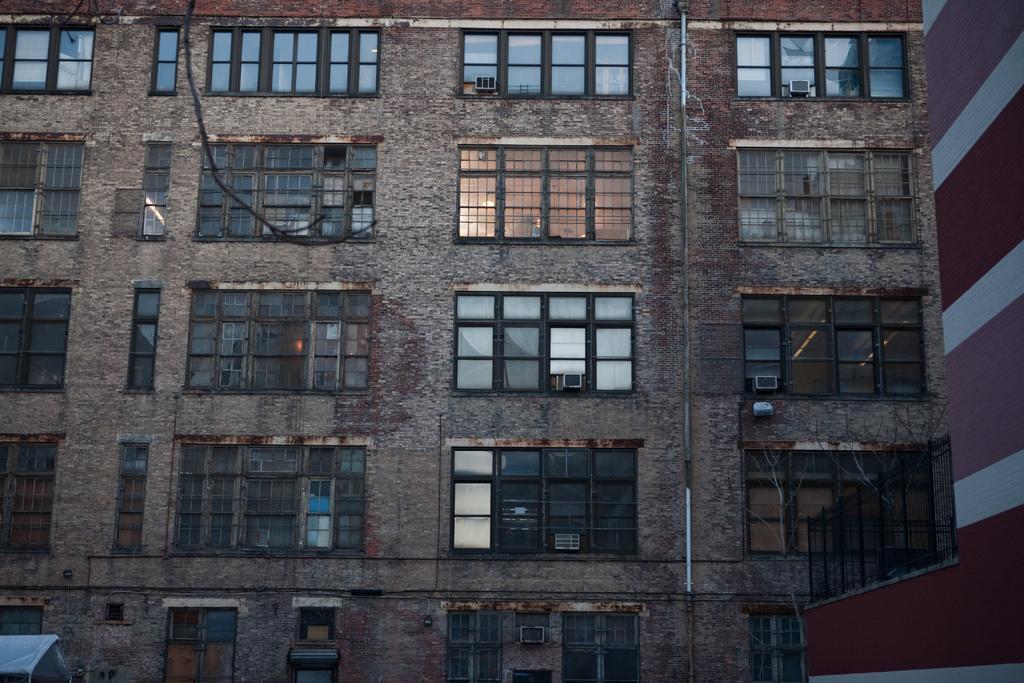Can you describe this image briefly? This is the picture of a building to which there are some glass windows and some other things. 